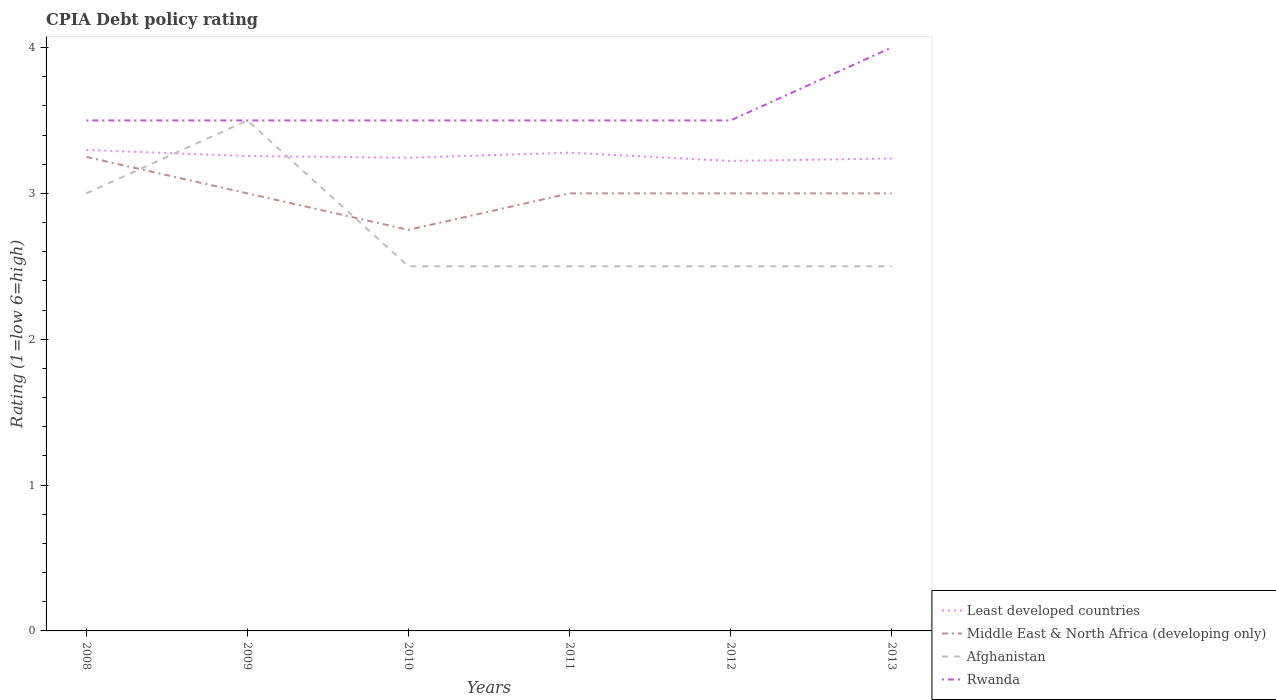Does the line corresponding to Middle East & North Africa (developing only) intersect with the line corresponding to Afghanistan?
Your response must be concise. Yes. Is the number of lines equal to the number of legend labels?
Offer a terse response. Yes. Across all years, what is the maximum CPIA rating in Least developed countries?
Your answer should be compact. 3.22. In which year was the CPIA rating in Middle East & North Africa (developing only) maximum?
Your response must be concise. 2010. What is the total CPIA rating in Rwanda in the graph?
Offer a very short reply. 0. What is the difference between the highest and the lowest CPIA rating in Rwanda?
Keep it short and to the point. 1. How many lines are there?
Give a very brief answer. 4. How many years are there in the graph?
Give a very brief answer. 6. What is the difference between two consecutive major ticks on the Y-axis?
Make the answer very short. 1. How many legend labels are there?
Keep it short and to the point. 4. How are the legend labels stacked?
Keep it short and to the point. Vertical. What is the title of the graph?
Keep it short and to the point. CPIA Debt policy rating. Does "Kosovo" appear as one of the legend labels in the graph?
Offer a very short reply. No. What is the label or title of the X-axis?
Provide a succinct answer. Years. What is the Rating (1=low 6=high) in Least developed countries in 2008?
Your answer should be compact. 3.3. What is the Rating (1=low 6=high) of Afghanistan in 2008?
Provide a succinct answer. 3. What is the Rating (1=low 6=high) in Rwanda in 2008?
Ensure brevity in your answer.  3.5. What is the Rating (1=low 6=high) in Least developed countries in 2009?
Provide a succinct answer. 3.26. What is the Rating (1=low 6=high) of Middle East & North Africa (developing only) in 2009?
Your answer should be very brief. 3. What is the Rating (1=low 6=high) of Least developed countries in 2010?
Provide a short and direct response. 3.24. What is the Rating (1=low 6=high) in Middle East & North Africa (developing only) in 2010?
Keep it short and to the point. 2.75. What is the Rating (1=low 6=high) in Afghanistan in 2010?
Make the answer very short. 2.5. What is the Rating (1=low 6=high) in Least developed countries in 2011?
Make the answer very short. 3.28. What is the Rating (1=low 6=high) in Middle East & North Africa (developing only) in 2011?
Give a very brief answer. 3. What is the Rating (1=low 6=high) of Afghanistan in 2011?
Your answer should be very brief. 2.5. What is the Rating (1=low 6=high) of Least developed countries in 2012?
Ensure brevity in your answer.  3.22. What is the Rating (1=low 6=high) of Least developed countries in 2013?
Provide a succinct answer. 3.24. What is the Rating (1=low 6=high) of Middle East & North Africa (developing only) in 2013?
Give a very brief answer. 3. What is the Rating (1=low 6=high) of Afghanistan in 2013?
Offer a very short reply. 2.5. What is the Rating (1=low 6=high) in Rwanda in 2013?
Give a very brief answer. 4. Across all years, what is the maximum Rating (1=low 6=high) of Least developed countries?
Give a very brief answer. 3.3. Across all years, what is the maximum Rating (1=low 6=high) of Afghanistan?
Make the answer very short. 3.5. Across all years, what is the maximum Rating (1=low 6=high) in Rwanda?
Your answer should be very brief. 4. Across all years, what is the minimum Rating (1=low 6=high) in Least developed countries?
Give a very brief answer. 3.22. Across all years, what is the minimum Rating (1=low 6=high) of Middle East & North Africa (developing only)?
Provide a short and direct response. 2.75. Across all years, what is the minimum Rating (1=low 6=high) in Afghanistan?
Keep it short and to the point. 2.5. What is the total Rating (1=low 6=high) of Least developed countries in the graph?
Provide a short and direct response. 19.54. What is the total Rating (1=low 6=high) in Afghanistan in the graph?
Give a very brief answer. 16.5. What is the total Rating (1=low 6=high) of Rwanda in the graph?
Keep it short and to the point. 21.5. What is the difference between the Rating (1=low 6=high) of Least developed countries in 2008 and that in 2009?
Keep it short and to the point. 0.04. What is the difference between the Rating (1=low 6=high) in Rwanda in 2008 and that in 2009?
Offer a terse response. 0. What is the difference between the Rating (1=low 6=high) in Least developed countries in 2008 and that in 2010?
Your answer should be compact. 0.05. What is the difference between the Rating (1=low 6=high) in Middle East & North Africa (developing only) in 2008 and that in 2010?
Offer a very short reply. 0.5. What is the difference between the Rating (1=low 6=high) of Afghanistan in 2008 and that in 2010?
Keep it short and to the point. 0.5. What is the difference between the Rating (1=low 6=high) of Rwanda in 2008 and that in 2010?
Keep it short and to the point. 0. What is the difference between the Rating (1=low 6=high) in Least developed countries in 2008 and that in 2011?
Provide a short and direct response. 0.02. What is the difference between the Rating (1=low 6=high) in Rwanda in 2008 and that in 2011?
Offer a terse response. 0. What is the difference between the Rating (1=low 6=high) of Least developed countries in 2008 and that in 2012?
Keep it short and to the point. 0.08. What is the difference between the Rating (1=low 6=high) in Middle East & North Africa (developing only) in 2008 and that in 2012?
Provide a succinct answer. 0.25. What is the difference between the Rating (1=low 6=high) of Afghanistan in 2008 and that in 2012?
Provide a short and direct response. 0.5. What is the difference between the Rating (1=low 6=high) in Rwanda in 2008 and that in 2012?
Make the answer very short. 0. What is the difference between the Rating (1=low 6=high) of Least developed countries in 2008 and that in 2013?
Provide a succinct answer. 0.06. What is the difference between the Rating (1=low 6=high) of Least developed countries in 2009 and that in 2010?
Provide a short and direct response. 0.01. What is the difference between the Rating (1=low 6=high) in Middle East & North Africa (developing only) in 2009 and that in 2010?
Give a very brief answer. 0.25. What is the difference between the Rating (1=low 6=high) of Rwanda in 2009 and that in 2010?
Keep it short and to the point. 0. What is the difference between the Rating (1=low 6=high) of Least developed countries in 2009 and that in 2011?
Provide a succinct answer. -0.02. What is the difference between the Rating (1=low 6=high) in Least developed countries in 2009 and that in 2012?
Your response must be concise. 0.03. What is the difference between the Rating (1=low 6=high) in Least developed countries in 2009 and that in 2013?
Make the answer very short. 0.02. What is the difference between the Rating (1=low 6=high) of Afghanistan in 2009 and that in 2013?
Keep it short and to the point. 1. What is the difference between the Rating (1=low 6=high) of Least developed countries in 2010 and that in 2011?
Keep it short and to the point. -0.03. What is the difference between the Rating (1=low 6=high) in Middle East & North Africa (developing only) in 2010 and that in 2011?
Give a very brief answer. -0.25. What is the difference between the Rating (1=low 6=high) in Rwanda in 2010 and that in 2011?
Ensure brevity in your answer.  0. What is the difference between the Rating (1=low 6=high) in Least developed countries in 2010 and that in 2012?
Your answer should be very brief. 0.02. What is the difference between the Rating (1=low 6=high) in Middle East & North Africa (developing only) in 2010 and that in 2012?
Your answer should be very brief. -0.25. What is the difference between the Rating (1=low 6=high) of Rwanda in 2010 and that in 2012?
Make the answer very short. 0. What is the difference between the Rating (1=low 6=high) of Least developed countries in 2010 and that in 2013?
Keep it short and to the point. 0.01. What is the difference between the Rating (1=low 6=high) in Middle East & North Africa (developing only) in 2010 and that in 2013?
Make the answer very short. -0.25. What is the difference between the Rating (1=low 6=high) of Least developed countries in 2011 and that in 2012?
Offer a terse response. 0.06. What is the difference between the Rating (1=low 6=high) of Afghanistan in 2011 and that in 2012?
Provide a succinct answer. 0. What is the difference between the Rating (1=low 6=high) of Rwanda in 2011 and that in 2012?
Your answer should be compact. 0. What is the difference between the Rating (1=low 6=high) in Least developed countries in 2011 and that in 2013?
Ensure brevity in your answer.  0.04. What is the difference between the Rating (1=low 6=high) in Middle East & North Africa (developing only) in 2011 and that in 2013?
Offer a very short reply. 0. What is the difference between the Rating (1=low 6=high) in Least developed countries in 2012 and that in 2013?
Keep it short and to the point. -0.02. What is the difference between the Rating (1=low 6=high) in Middle East & North Africa (developing only) in 2012 and that in 2013?
Your answer should be compact. 0. What is the difference between the Rating (1=low 6=high) in Rwanda in 2012 and that in 2013?
Keep it short and to the point. -0.5. What is the difference between the Rating (1=low 6=high) in Least developed countries in 2008 and the Rating (1=low 6=high) in Middle East & North Africa (developing only) in 2009?
Offer a terse response. 0.3. What is the difference between the Rating (1=low 6=high) in Least developed countries in 2008 and the Rating (1=low 6=high) in Afghanistan in 2009?
Make the answer very short. -0.2. What is the difference between the Rating (1=low 6=high) of Least developed countries in 2008 and the Rating (1=low 6=high) of Rwanda in 2009?
Provide a succinct answer. -0.2. What is the difference between the Rating (1=low 6=high) of Middle East & North Africa (developing only) in 2008 and the Rating (1=low 6=high) of Rwanda in 2009?
Your answer should be compact. -0.25. What is the difference between the Rating (1=low 6=high) in Least developed countries in 2008 and the Rating (1=low 6=high) in Middle East & North Africa (developing only) in 2010?
Your answer should be very brief. 0.55. What is the difference between the Rating (1=low 6=high) in Least developed countries in 2008 and the Rating (1=low 6=high) in Afghanistan in 2010?
Give a very brief answer. 0.8. What is the difference between the Rating (1=low 6=high) of Least developed countries in 2008 and the Rating (1=low 6=high) of Rwanda in 2010?
Your answer should be compact. -0.2. What is the difference between the Rating (1=low 6=high) of Middle East & North Africa (developing only) in 2008 and the Rating (1=low 6=high) of Afghanistan in 2010?
Ensure brevity in your answer.  0.75. What is the difference between the Rating (1=low 6=high) in Middle East & North Africa (developing only) in 2008 and the Rating (1=low 6=high) in Rwanda in 2010?
Ensure brevity in your answer.  -0.25. What is the difference between the Rating (1=low 6=high) in Least developed countries in 2008 and the Rating (1=low 6=high) in Middle East & North Africa (developing only) in 2011?
Make the answer very short. 0.3. What is the difference between the Rating (1=low 6=high) in Least developed countries in 2008 and the Rating (1=low 6=high) in Afghanistan in 2011?
Offer a very short reply. 0.8. What is the difference between the Rating (1=low 6=high) in Least developed countries in 2008 and the Rating (1=low 6=high) in Rwanda in 2011?
Keep it short and to the point. -0.2. What is the difference between the Rating (1=low 6=high) in Middle East & North Africa (developing only) in 2008 and the Rating (1=low 6=high) in Afghanistan in 2011?
Make the answer very short. 0.75. What is the difference between the Rating (1=low 6=high) in Least developed countries in 2008 and the Rating (1=low 6=high) in Middle East & North Africa (developing only) in 2012?
Your response must be concise. 0.3. What is the difference between the Rating (1=low 6=high) of Least developed countries in 2008 and the Rating (1=low 6=high) of Afghanistan in 2012?
Offer a terse response. 0.8. What is the difference between the Rating (1=low 6=high) in Least developed countries in 2008 and the Rating (1=low 6=high) in Rwanda in 2012?
Make the answer very short. -0.2. What is the difference between the Rating (1=low 6=high) in Least developed countries in 2008 and the Rating (1=low 6=high) in Middle East & North Africa (developing only) in 2013?
Your response must be concise. 0.3. What is the difference between the Rating (1=low 6=high) of Least developed countries in 2008 and the Rating (1=low 6=high) of Afghanistan in 2013?
Your answer should be very brief. 0.8. What is the difference between the Rating (1=low 6=high) of Least developed countries in 2008 and the Rating (1=low 6=high) of Rwanda in 2013?
Your response must be concise. -0.7. What is the difference between the Rating (1=low 6=high) of Middle East & North Africa (developing only) in 2008 and the Rating (1=low 6=high) of Afghanistan in 2013?
Offer a terse response. 0.75. What is the difference between the Rating (1=low 6=high) in Middle East & North Africa (developing only) in 2008 and the Rating (1=low 6=high) in Rwanda in 2013?
Provide a short and direct response. -0.75. What is the difference between the Rating (1=low 6=high) in Afghanistan in 2008 and the Rating (1=low 6=high) in Rwanda in 2013?
Make the answer very short. -1. What is the difference between the Rating (1=low 6=high) of Least developed countries in 2009 and the Rating (1=low 6=high) of Middle East & North Africa (developing only) in 2010?
Ensure brevity in your answer.  0.51. What is the difference between the Rating (1=low 6=high) of Least developed countries in 2009 and the Rating (1=low 6=high) of Afghanistan in 2010?
Your answer should be compact. 0.76. What is the difference between the Rating (1=low 6=high) in Least developed countries in 2009 and the Rating (1=low 6=high) in Rwanda in 2010?
Make the answer very short. -0.24. What is the difference between the Rating (1=low 6=high) in Middle East & North Africa (developing only) in 2009 and the Rating (1=low 6=high) in Afghanistan in 2010?
Offer a terse response. 0.5. What is the difference between the Rating (1=low 6=high) of Least developed countries in 2009 and the Rating (1=low 6=high) of Middle East & North Africa (developing only) in 2011?
Keep it short and to the point. 0.26. What is the difference between the Rating (1=low 6=high) in Least developed countries in 2009 and the Rating (1=low 6=high) in Afghanistan in 2011?
Your answer should be compact. 0.76. What is the difference between the Rating (1=low 6=high) in Least developed countries in 2009 and the Rating (1=low 6=high) in Rwanda in 2011?
Ensure brevity in your answer.  -0.24. What is the difference between the Rating (1=low 6=high) of Middle East & North Africa (developing only) in 2009 and the Rating (1=low 6=high) of Afghanistan in 2011?
Offer a very short reply. 0.5. What is the difference between the Rating (1=low 6=high) in Middle East & North Africa (developing only) in 2009 and the Rating (1=low 6=high) in Rwanda in 2011?
Your response must be concise. -0.5. What is the difference between the Rating (1=low 6=high) of Least developed countries in 2009 and the Rating (1=low 6=high) of Middle East & North Africa (developing only) in 2012?
Your answer should be very brief. 0.26. What is the difference between the Rating (1=low 6=high) in Least developed countries in 2009 and the Rating (1=low 6=high) in Afghanistan in 2012?
Provide a succinct answer. 0.76. What is the difference between the Rating (1=low 6=high) in Least developed countries in 2009 and the Rating (1=low 6=high) in Rwanda in 2012?
Offer a terse response. -0.24. What is the difference between the Rating (1=low 6=high) in Middle East & North Africa (developing only) in 2009 and the Rating (1=low 6=high) in Afghanistan in 2012?
Your answer should be very brief. 0.5. What is the difference between the Rating (1=low 6=high) of Middle East & North Africa (developing only) in 2009 and the Rating (1=low 6=high) of Rwanda in 2012?
Ensure brevity in your answer.  -0.5. What is the difference between the Rating (1=low 6=high) in Afghanistan in 2009 and the Rating (1=low 6=high) in Rwanda in 2012?
Provide a succinct answer. 0. What is the difference between the Rating (1=low 6=high) in Least developed countries in 2009 and the Rating (1=low 6=high) in Middle East & North Africa (developing only) in 2013?
Offer a terse response. 0.26. What is the difference between the Rating (1=low 6=high) of Least developed countries in 2009 and the Rating (1=low 6=high) of Afghanistan in 2013?
Provide a succinct answer. 0.76. What is the difference between the Rating (1=low 6=high) in Least developed countries in 2009 and the Rating (1=low 6=high) in Rwanda in 2013?
Provide a short and direct response. -0.74. What is the difference between the Rating (1=low 6=high) of Afghanistan in 2009 and the Rating (1=low 6=high) of Rwanda in 2013?
Your answer should be very brief. -0.5. What is the difference between the Rating (1=low 6=high) of Least developed countries in 2010 and the Rating (1=low 6=high) of Middle East & North Africa (developing only) in 2011?
Your response must be concise. 0.24. What is the difference between the Rating (1=low 6=high) in Least developed countries in 2010 and the Rating (1=low 6=high) in Afghanistan in 2011?
Keep it short and to the point. 0.74. What is the difference between the Rating (1=low 6=high) of Least developed countries in 2010 and the Rating (1=low 6=high) of Rwanda in 2011?
Give a very brief answer. -0.26. What is the difference between the Rating (1=low 6=high) in Middle East & North Africa (developing only) in 2010 and the Rating (1=low 6=high) in Rwanda in 2011?
Your answer should be compact. -0.75. What is the difference between the Rating (1=low 6=high) in Afghanistan in 2010 and the Rating (1=low 6=high) in Rwanda in 2011?
Your answer should be compact. -1. What is the difference between the Rating (1=low 6=high) in Least developed countries in 2010 and the Rating (1=low 6=high) in Middle East & North Africa (developing only) in 2012?
Provide a short and direct response. 0.24. What is the difference between the Rating (1=low 6=high) of Least developed countries in 2010 and the Rating (1=low 6=high) of Afghanistan in 2012?
Offer a terse response. 0.74. What is the difference between the Rating (1=low 6=high) in Least developed countries in 2010 and the Rating (1=low 6=high) in Rwanda in 2012?
Your answer should be compact. -0.26. What is the difference between the Rating (1=low 6=high) in Middle East & North Africa (developing only) in 2010 and the Rating (1=low 6=high) in Rwanda in 2012?
Your answer should be compact. -0.75. What is the difference between the Rating (1=low 6=high) in Least developed countries in 2010 and the Rating (1=low 6=high) in Middle East & North Africa (developing only) in 2013?
Give a very brief answer. 0.24. What is the difference between the Rating (1=low 6=high) of Least developed countries in 2010 and the Rating (1=low 6=high) of Afghanistan in 2013?
Provide a succinct answer. 0.74. What is the difference between the Rating (1=low 6=high) in Least developed countries in 2010 and the Rating (1=low 6=high) in Rwanda in 2013?
Your response must be concise. -0.76. What is the difference between the Rating (1=low 6=high) of Middle East & North Africa (developing only) in 2010 and the Rating (1=low 6=high) of Afghanistan in 2013?
Provide a succinct answer. 0.25. What is the difference between the Rating (1=low 6=high) in Middle East & North Africa (developing only) in 2010 and the Rating (1=low 6=high) in Rwanda in 2013?
Offer a terse response. -1.25. What is the difference between the Rating (1=low 6=high) of Least developed countries in 2011 and the Rating (1=low 6=high) of Middle East & North Africa (developing only) in 2012?
Make the answer very short. 0.28. What is the difference between the Rating (1=low 6=high) of Least developed countries in 2011 and the Rating (1=low 6=high) of Afghanistan in 2012?
Your answer should be compact. 0.78. What is the difference between the Rating (1=low 6=high) of Least developed countries in 2011 and the Rating (1=low 6=high) of Rwanda in 2012?
Make the answer very short. -0.22. What is the difference between the Rating (1=low 6=high) of Middle East & North Africa (developing only) in 2011 and the Rating (1=low 6=high) of Rwanda in 2012?
Provide a short and direct response. -0.5. What is the difference between the Rating (1=low 6=high) of Afghanistan in 2011 and the Rating (1=low 6=high) of Rwanda in 2012?
Ensure brevity in your answer.  -1. What is the difference between the Rating (1=low 6=high) of Least developed countries in 2011 and the Rating (1=low 6=high) of Middle East & North Africa (developing only) in 2013?
Offer a terse response. 0.28. What is the difference between the Rating (1=low 6=high) of Least developed countries in 2011 and the Rating (1=low 6=high) of Afghanistan in 2013?
Keep it short and to the point. 0.78. What is the difference between the Rating (1=low 6=high) in Least developed countries in 2011 and the Rating (1=low 6=high) in Rwanda in 2013?
Keep it short and to the point. -0.72. What is the difference between the Rating (1=low 6=high) in Middle East & North Africa (developing only) in 2011 and the Rating (1=low 6=high) in Afghanistan in 2013?
Make the answer very short. 0.5. What is the difference between the Rating (1=low 6=high) of Middle East & North Africa (developing only) in 2011 and the Rating (1=low 6=high) of Rwanda in 2013?
Your response must be concise. -1. What is the difference between the Rating (1=low 6=high) of Afghanistan in 2011 and the Rating (1=low 6=high) of Rwanda in 2013?
Your answer should be very brief. -1.5. What is the difference between the Rating (1=low 6=high) in Least developed countries in 2012 and the Rating (1=low 6=high) in Middle East & North Africa (developing only) in 2013?
Your response must be concise. 0.22. What is the difference between the Rating (1=low 6=high) in Least developed countries in 2012 and the Rating (1=low 6=high) in Afghanistan in 2013?
Offer a very short reply. 0.72. What is the difference between the Rating (1=low 6=high) in Least developed countries in 2012 and the Rating (1=low 6=high) in Rwanda in 2013?
Your response must be concise. -0.78. What is the difference between the Rating (1=low 6=high) of Middle East & North Africa (developing only) in 2012 and the Rating (1=low 6=high) of Afghanistan in 2013?
Provide a short and direct response. 0.5. What is the difference between the Rating (1=low 6=high) of Middle East & North Africa (developing only) in 2012 and the Rating (1=low 6=high) of Rwanda in 2013?
Offer a very short reply. -1. What is the difference between the Rating (1=low 6=high) of Afghanistan in 2012 and the Rating (1=low 6=high) of Rwanda in 2013?
Ensure brevity in your answer.  -1.5. What is the average Rating (1=low 6=high) in Least developed countries per year?
Keep it short and to the point. 3.26. What is the average Rating (1=low 6=high) in Middle East & North Africa (developing only) per year?
Provide a succinct answer. 3. What is the average Rating (1=low 6=high) in Afghanistan per year?
Offer a very short reply. 2.75. What is the average Rating (1=low 6=high) in Rwanda per year?
Provide a short and direct response. 3.58. In the year 2008, what is the difference between the Rating (1=low 6=high) of Least developed countries and Rating (1=low 6=high) of Middle East & North Africa (developing only)?
Provide a succinct answer. 0.05. In the year 2008, what is the difference between the Rating (1=low 6=high) in Least developed countries and Rating (1=low 6=high) in Afghanistan?
Your answer should be very brief. 0.3. In the year 2008, what is the difference between the Rating (1=low 6=high) in Least developed countries and Rating (1=low 6=high) in Rwanda?
Ensure brevity in your answer.  -0.2. In the year 2008, what is the difference between the Rating (1=low 6=high) in Middle East & North Africa (developing only) and Rating (1=low 6=high) in Afghanistan?
Make the answer very short. 0.25. In the year 2008, what is the difference between the Rating (1=low 6=high) of Middle East & North Africa (developing only) and Rating (1=low 6=high) of Rwanda?
Your answer should be very brief. -0.25. In the year 2008, what is the difference between the Rating (1=low 6=high) in Afghanistan and Rating (1=low 6=high) in Rwanda?
Your answer should be very brief. -0.5. In the year 2009, what is the difference between the Rating (1=low 6=high) of Least developed countries and Rating (1=low 6=high) of Middle East & North Africa (developing only)?
Your answer should be very brief. 0.26. In the year 2009, what is the difference between the Rating (1=low 6=high) in Least developed countries and Rating (1=low 6=high) in Afghanistan?
Give a very brief answer. -0.24. In the year 2009, what is the difference between the Rating (1=low 6=high) in Least developed countries and Rating (1=low 6=high) in Rwanda?
Your response must be concise. -0.24. In the year 2009, what is the difference between the Rating (1=low 6=high) of Middle East & North Africa (developing only) and Rating (1=low 6=high) of Afghanistan?
Your response must be concise. -0.5. In the year 2010, what is the difference between the Rating (1=low 6=high) of Least developed countries and Rating (1=low 6=high) of Middle East & North Africa (developing only)?
Make the answer very short. 0.49. In the year 2010, what is the difference between the Rating (1=low 6=high) of Least developed countries and Rating (1=low 6=high) of Afghanistan?
Your answer should be very brief. 0.74. In the year 2010, what is the difference between the Rating (1=low 6=high) in Least developed countries and Rating (1=low 6=high) in Rwanda?
Keep it short and to the point. -0.26. In the year 2010, what is the difference between the Rating (1=low 6=high) of Middle East & North Africa (developing only) and Rating (1=low 6=high) of Rwanda?
Provide a succinct answer. -0.75. In the year 2011, what is the difference between the Rating (1=low 6=high) in Least developed countries and Rating (1=low 6=high) in Middle East & North Africa (developing only)?
Your answer should be very brief. 0.28. In the year 2011, what is the difference between the Rating (1=low 6=high) of Least developed countries and Rating (1=low 6=high) of Afghanistan?
Offer a very short reply. 0.78. In the year 2011, what is the difference between the Rating (1=low 6=high) of Least developed countries and Rating (1=low 6=high) of Rwanda?
Your response must be concise. -0.22. In the year 2011, what is the difference between the Rating (1=low 6=high) in Middle East & North Africa (developing only) and Rating (1=low 6=high) in Afghanistan?
Your response must be concise. 0.5. In the year 2011, what is the difference between the Rating (1=low 6=high) in Middle East & North Africa (developing only) and Rating (1=low 6=high) in Rwanda?
Your answer should be compact. -0.5. In the year 2011, what is the difference between the Rating (1=low 6=high) of Afghanistan and Rating (1=low 6=high) of Rwanda?
Provide a short and direct response. -1. In the year 2012, what is the difference between the Rating (1=low 6=high) of Least developed countries and Rating (1=low 6=high) of Middle East & North Africa (developing only)?
Keep it short and to the point. 0.22. In the year 2012, what is the difference between the Rating (1=low 6=high) of Least developed countries and Rating (1=low 6=high) of Afghanistan?
Keep it short and to the point. 0.72. In the year 2012, what is the difference between the Rating (1=low 6=high) in Least developed countries and Rating (1=low 6=high) in Rwanda?
Offer a terse response. -0.28. In the year 2012, what is the difference between the Rating (1=low 6=high) of Afghanistan and Rating (1=low 6=high) of Rwanda?
Give a very brief answer. -1. In the year 2013, what is the difference between the Rating (1=low 6=high) of Least developed countries and Rating (1=low 6=high) of Middle East & North Africa (developing only)?
Offer a terse response. 0.24. In the year 2013, what is the difference between the Rating (1=low 6=high) in Least developed countries and Rating (1=low 6=high) in Afghanistan?
Offer a very short reply. 0.74. In the year 2013, what is the difference between the Rating (1=low 6=high) in Least developed countries and Rating (1=low 6=high) in Rwanda?
Give a very brief answer. -0.76. In the year 2013, what is the difference between the Rating (1=low 6=high) of Middle East & North Africa (developing only) and Rating (1=low 6=high) of Afghanistan?
Ensure brevity in your answer.  0.5. What is the ratio of the Rating (1=low 6=high) in Least developed countries in 2008 to that in 2009?
Make the answer very short. 1.01. What is the ratio of the Rating (1=low 6=high) in Afghanistan in 2008 to that in 2009?
Provide a succinct answer. 0.86. What is the ratio of the Rating (1=low 6=high) in Least developed countries in 2008 to that in 2010?
Make the answer very short. 1.02. What is the ratio of the Rating (1=low 6=high) in Middle East & North Africa (developing only) in 2008 to that in 2010?
Keep it short and to the point. 1.18. What is the ratio of the Rating (1=low 6=high) in Afghanistan in 2008 to that in 2010?
Keep it short and to the point. 1.2. What is the ratio of the Rating (1=low 6=high) in Rwanda in 2008 to that in 2010?
Offer a very short reply. 1. What is the ratio of the Rating (1=low 6=high) of Least developed countries in 2008 to that in 2011?
Keep it short and to the point. 1.01. What is the ratio of the Rating (1=low 6=high) of Middle East & North Africa (developing only) in 2008 to that in 2011?
Your answer should be compact. 1.08. What is the ratio of the Rating (1=low 6=high) in Afghanistan in 2008 to that in 2011?
Ensure brevity in your answer.  1.2. What is the ratio of the Rating (1=low 6=high) in Least developed countries in 2008 to that in 2012?
Ensure brevity in your answer.  1.02. What is the ratio of the Rating (1=low 6=high) in Middle East & North Africa (developing only) in 2008 to that in 2012?
Your answer should be very brief. 1.08. What is the ratio of the Rating (1=low 6=high) in Afghanistan in 2008 to that in 2012?
Your answer should be compact. 1.2. What is the ratio of the Rating (1=low 6=high) of Least developed countries in 2008 to that in 2013?
Offer a very short reply. 1.02. What is the ratio of the Rating (1=low 6=high) in Middle East & North Africa (developing only) in 2009 to that in 2010?
Ensure brevity in your answer.  1.09. What is the ratio of the Rating (1=low 6=high) of Afghanistan in 2009 to that in 2010?
Give a very brief answer. 1.4. What is the ratio of the Rating (1=low 6=high) in Rwanda in 2009 to that in 2010?
Your answer should be very brief. 1. What is the ratio of the Rating (1=low 6=high) in Middle East & North Africa (developing only) in 2009 to that in 2011?
Ensure brevity in your answer.  1. What is the ratio of the Rating (1=low 6=high) in Afghanistan in 2009 to that in 2011?
Offer a very short reply. 1.4. What is the ratio of the Rating (1=low 6=high) in Least developed countries in 2009 to that in 2012?
Your answer should be compact. 1.01. What is the ratio of the Rating (1=low 6=high) in Rwanda in 2009 to that in 2012?
Keep it short and to the point. 1. What is the ratio of the Rating (1=low 6=high) of Rwanda in 2009 to that in 2013?
Provide a succinct answer. 0.88. What is the ratio of the Rating (1=low 6=high) of Least developed countries in 2010 to that in 2011?
Make the answer very short. 0.99. What is the ratio of the Rating (1=low 6=high) in Afghanistan in 2010 to that in 2011?
Your response must be concise. 1. What is the ratio of the Rating (1=low 6=high) in Least developed countries in 2010 to that in 2012?
Your answer should be compact. 1.01. What is the ratio of the Rating (1=low 6=high) of Afghanistan in 2010 to that in 2012?
Ensure brevity in your answer.  1. What is the ratio of the Rating (1=low 6=high) of Rwanda in 2010 to that in 2012?
Offer a terse response. 1. What is the ratio of the Rating (1=low 6=high) in Least developed countries in 2010 to that in 2013?
Give a very brief answer. 1. What is the ratio of the Rating (1=low 6=high) in Least developed countries in 2011 to that in 2012?
Your response must be concise. 1.02. What is the ratio of the Rating (1=low 6=high) of Middle East & North Africa (developing only) in 2011 to that in 2012?
Offer a very short reply. 1. What is the ratio of the Rating (1=low 6=high) of Rwanda in 2011 to that in 2012?
Your answer should be very brief. 1. What is the ratio of the Rating (1=low 6=high) of Least developed countries in 2011 to that in 2013?
Make the answer very short. 1.01. What is the ratio of the Rating (1=low 6=high) of Middle East & North Africa (developing only) in 2011 to that in 2013?
Offer a terse response. 1. What is the ratio of the Rating (1=low 6=high) in Least developed countries in 2012 to that in 2013?
Make the answer very short. 0.99. What is the ratio of the Rating (1=low 6=high) in Afghanistan in 2012 to that in 2013?
Offer a terse response. 1. What is the difference between the highest and the second highest Rating (1=low 6=high) in Least developed countries?
Ensure brevity in your answer.  0.02. What is the difference between the highest and the second highest Rating (1=low 6=high) of Middle East & North Africa (developing only)?
Your response must be concise. 0.25. What is the difference between the highest and the lowest Rating (1=low 6=high) in Least developed countries?
Give a very brief answer. 0.08. What is the difference between the highest and the lowest Rating (1=low 6=high) in Middle East & North Africa (developing only)?
Make the answer very short. 0.5. What is the difference between the highest and the lowest Rating (1=low 6=high) in Rwanda?
Give a very brief answer. 0.5. 